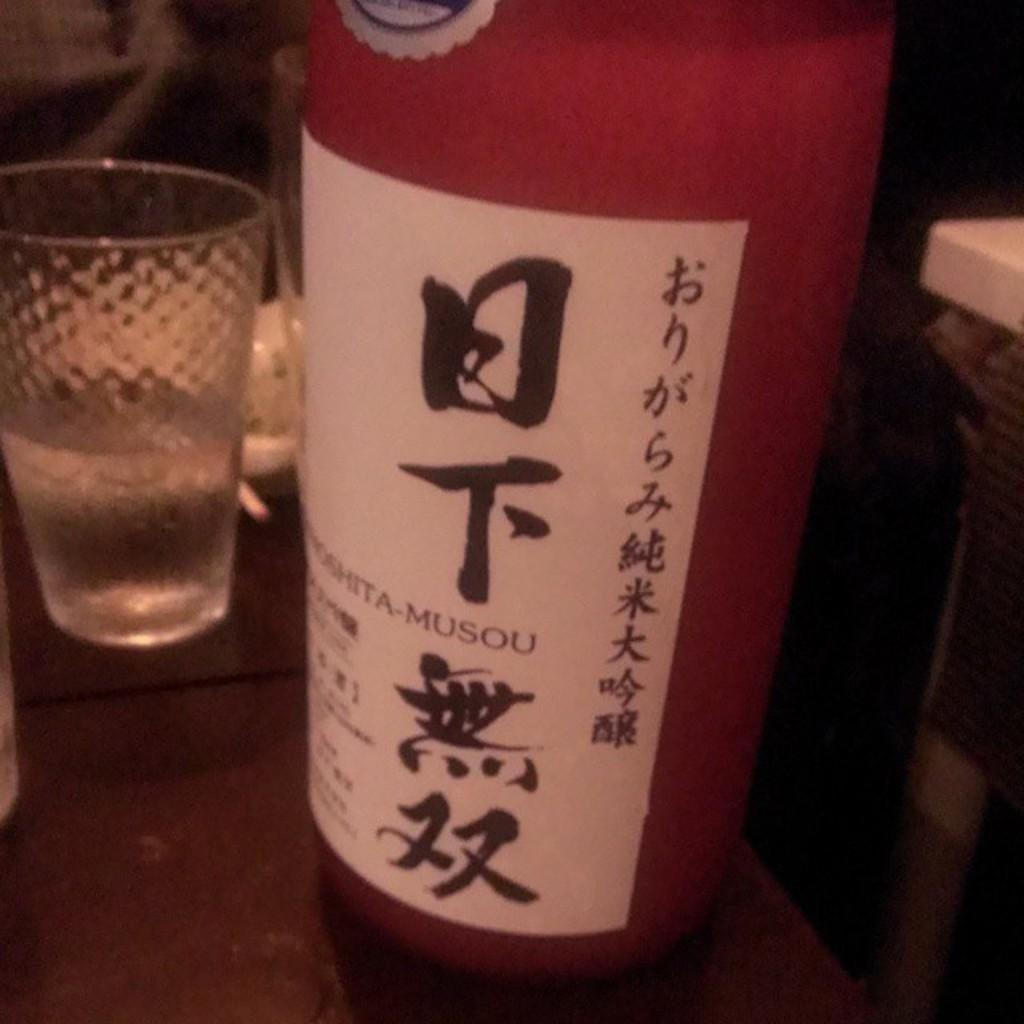What is the main object in the foreground of the image? There is an object that appears to be a bottle in the foreground of the image. What is attached to the bottle? There is text on a paper attached to the bottle. Can you describe another object visible in the image? There is a glass visible in the image. What other unspecified objects can be seen in the image? There are other unspecified objects in the image, but their details are not provided. What type of music is being played by the beginner in the image? There is no indication of music or a beginner in the image; it features a bottle with text on a paper and a glass. 